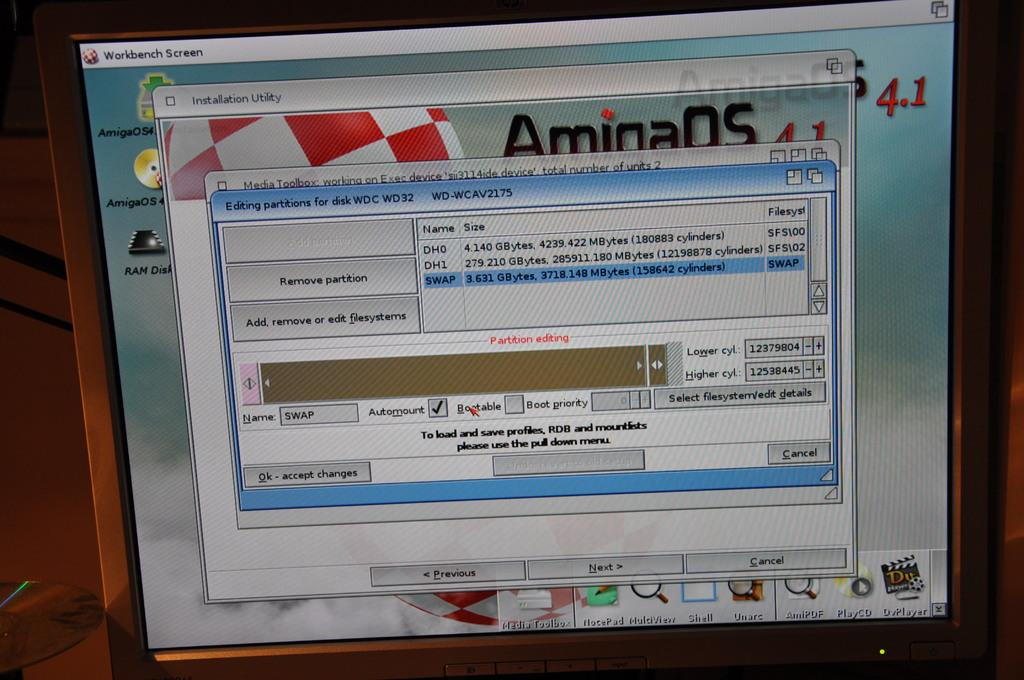<image>
Share a concise interpretation of the image provided. A partitioning program is opened on a computer display. 